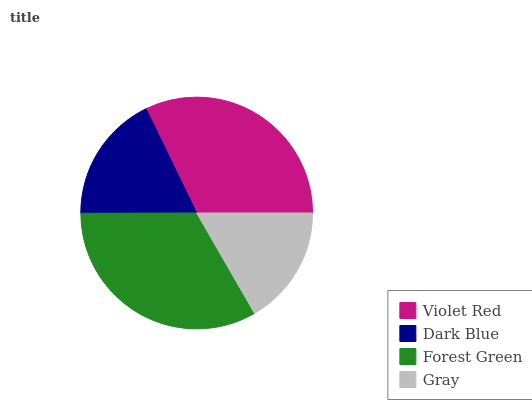Is Gray the minimum?
Answer yes or no. Yes. Is Forest Green the maximum?
Answer yes or no. Yes. Is Dark Blue the minimum?
Answer yes or no. No. Is Dark Blue the maximum?
Answer yes or no. No. Is Violet Red greater than Dark Blue?
Answer yes or no. Yes. Is Dark Blue less than Violet Red?
Answer yes or no. Yes. Is Dark Blue greater than Violet Red?
Answer yes or no. No. Is Violet Red less than Dark Blue?
Answer yes or no. No. Is Violet Red the high median?
Answer yes or no. Yes. Is Dark Blue the low median?
Answer yes or no. Yes. Is Dark Blue the high median?
Answer yes or no. No. Is Forest Green the low median?
Answer yes or no. No. 